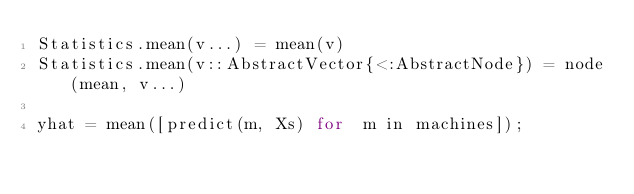Convert code to text. <code><loc_0><loc_0><loc_500><loc_500><_Julia_>Statistics.mean(v...) = mean(v)
Statistics.mean(v::AbstractVector{<:AbstractNode}) = node(mean, v...)

yhat = mean([predict(m, Xs) for  m in machines]);</code> 